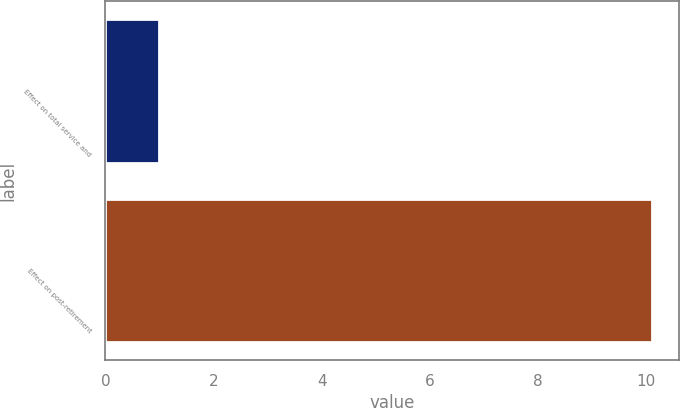<chart> <loc_0><loc_0><loc_500><loc_500><bar_chart><fcel>Effect on total service and<fcel>Effect on post-retirement<nl><fcel>1<fcel>10.1<nl></chart> 